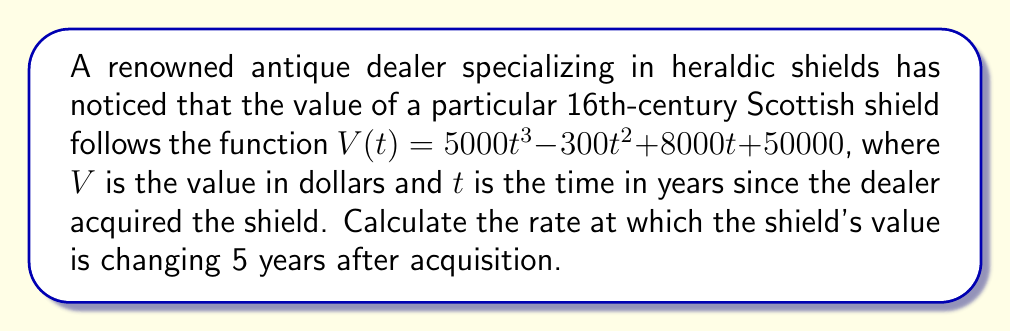What is the answer to this math problem? To solve this problem, we need to find the derivative of the given function and then evaluate it at $t = 5$. This will give us the instantaneous rate of change of the shield's value at that point in time.

1. First, let's find the derivative of $V(t)$:

   $V(t) = 5000t^3 - 300t^2 + 8000t + 50000$
   
   $V'(t) = \frac{d}{dt}[5000t^3 - 300t^2 + 8000t + 50000]$
   
   $V'(t) = 15000t^2 - 600t + 8000$

2. Now that we have the derivative, we can evaluate it at $t = 5$:

   $V'(5) = 15000(5)^2 - 600(5) + 8000$
   
   $V'(5) = 15000(25) - 3000 + 8000$
   
   $V'(5) = 375000 - 3000 + 8000$
   
   $V'(5) = 380000$

3. Interpret the result:
   The rate of change of the shield's value after 5 years is $380,000 dollars per year.
Answer: $380,000 dollars per year 